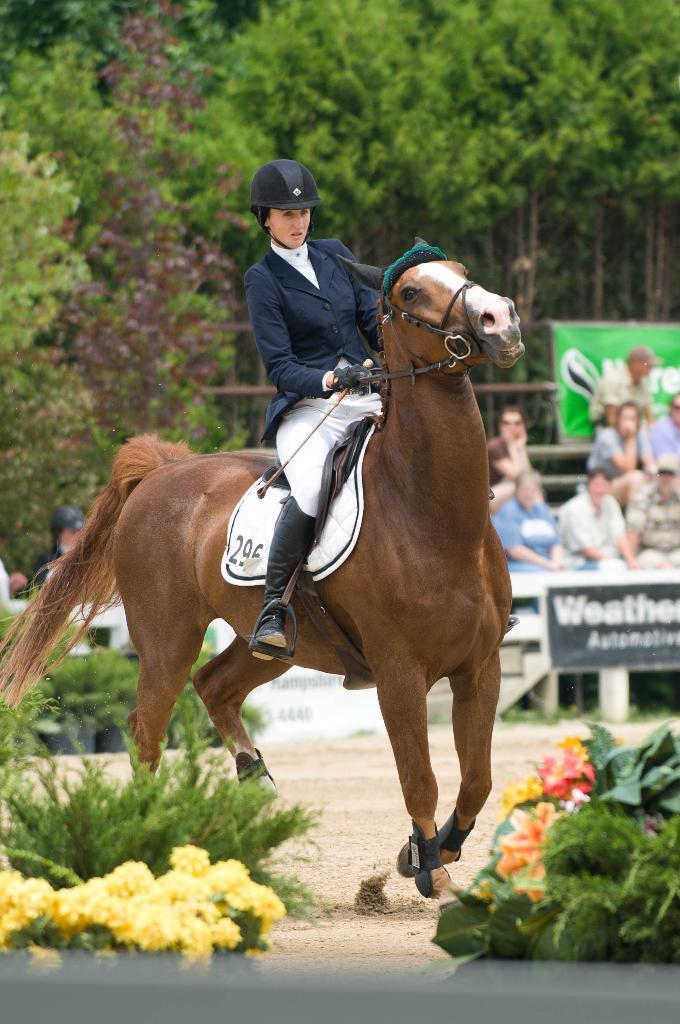What is the woman in the image doing? The woman is riding a horse in the image. What can be seen in the background of the image? There are people and trees in the background of the image. Are there any plants visible in the image? Yes, there are flowers visible in the image. Where is the stove located in the image? There is no stove present in the image. How many pigs can be seen in the image? There are no pigs present in the image. 